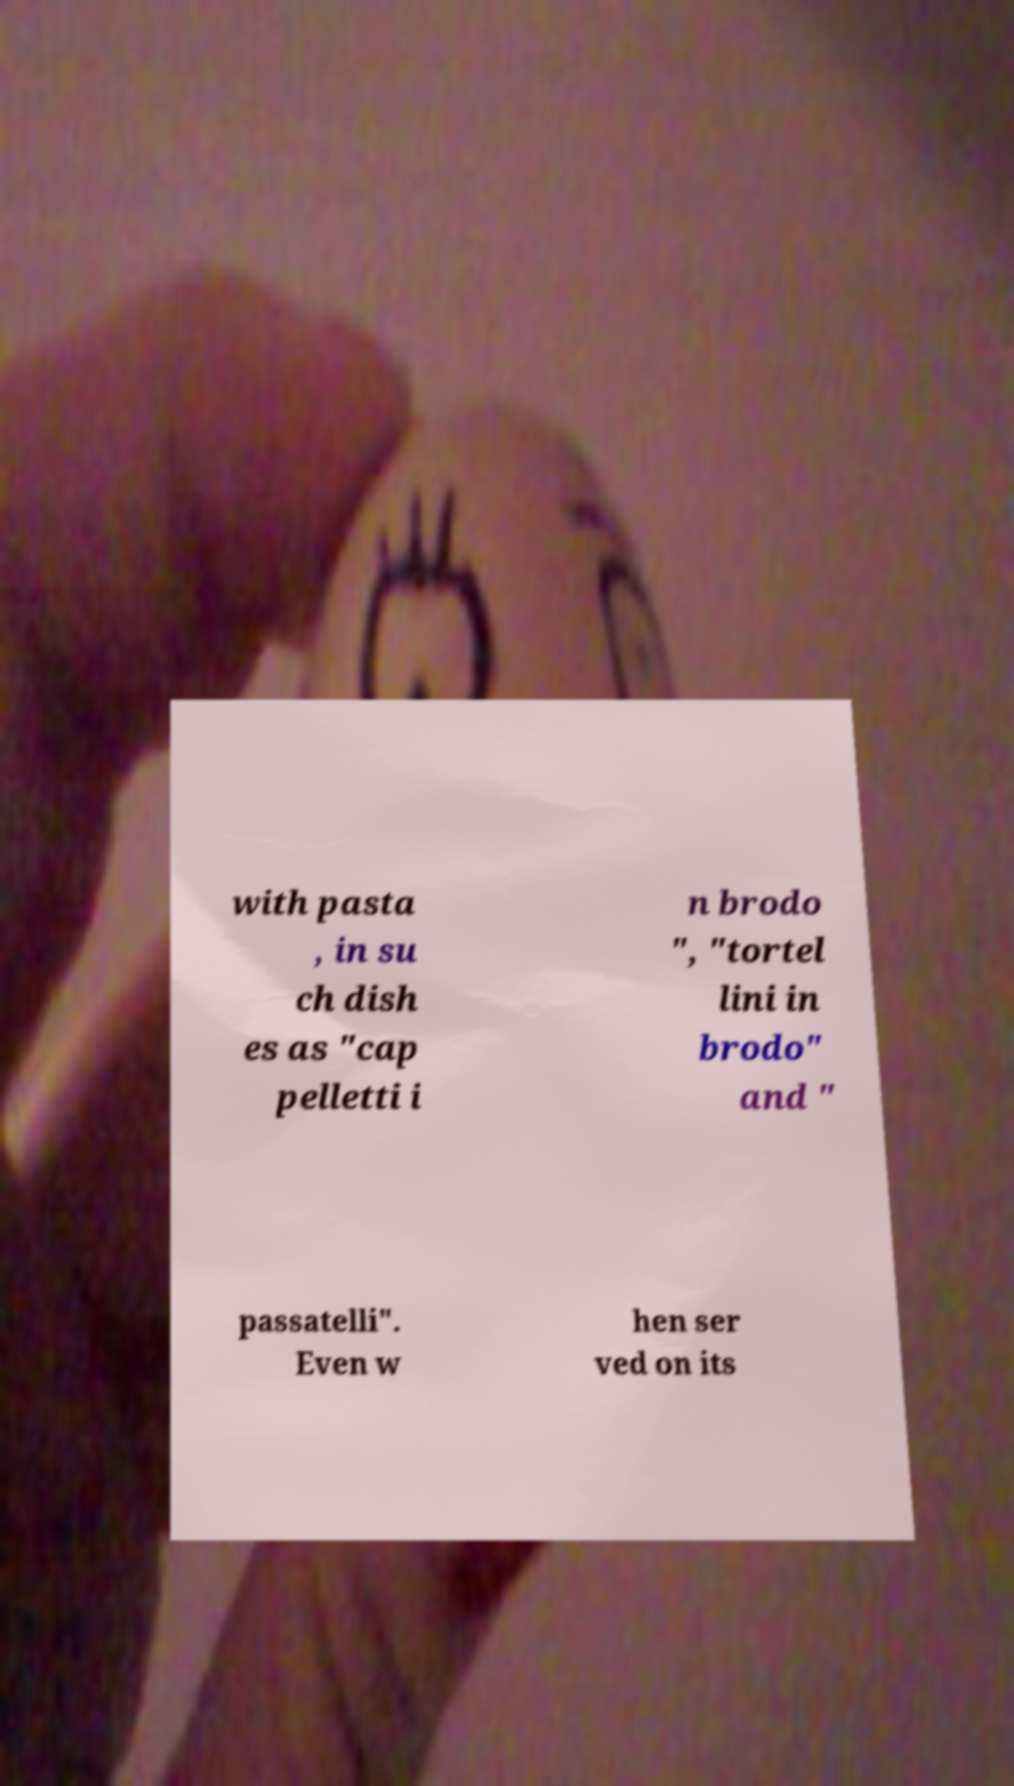There's text embedded in this image that I need extracted. Can you transcribe it verbatim? with pasta , in su ch dish es as "cap pelletti i n brodo ", "tortel lini in brodo" and " passatelli". Even w hen ser ved on its 